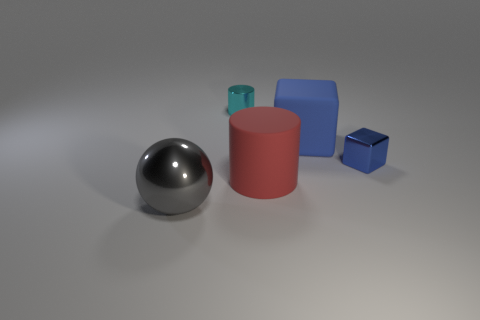Add 1 tiny shiny cylinders. How many objects exist? 6 Subtract all cylinders. How many objects are left? 3 Add 1 small matte blocks. How many small matte blocks exist? 1 Subtract 1 cyan cylinders. How many objects are left? 4 Subtract all large green metal things. Subtract all tiny cyan objects. How many objects are left? 4 Add 5 gray spheres. How many gray spheres are left? 6 